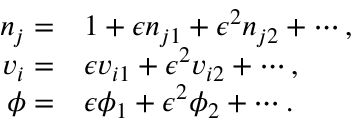<formula> <loc_0><loc_0><loc_500><loc_500>\begin{array} { r l } { n _ { j } = } & 1 + \epsilon n _ { j 1 } + \epsilon ^ { 2 } n _ { j 2 } + \cdots , } \\ { v _ { i } = } & \epsilon v _ { i 1 } + \epsilon ^ { 2 } v _ { i 2 } + \cdots , } \\ { \phi = } & \epsilon \phi _ { 1 } + \epsilon ^ { 2 } \phi _ { 2 } + \cdots . } \end{array}</formula> 